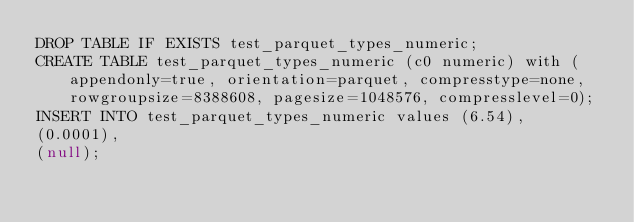<code> <loc_0><loc_0><loc_500><loc_500><_SQL_>DROP TABLE IF EXISTS test_parquet_types_numeric;
CREATE TABLE test_parquet_types_numeric (c0 numeric) with (appendonly=true, orientation=parquet, compresstype=none, rowgroupsize=8388608, pagesize=1048576, compresslevel=0);
INSERT INTO test_parquet_types_numeric values (6.54),
(0.0001),
(null);</code> 